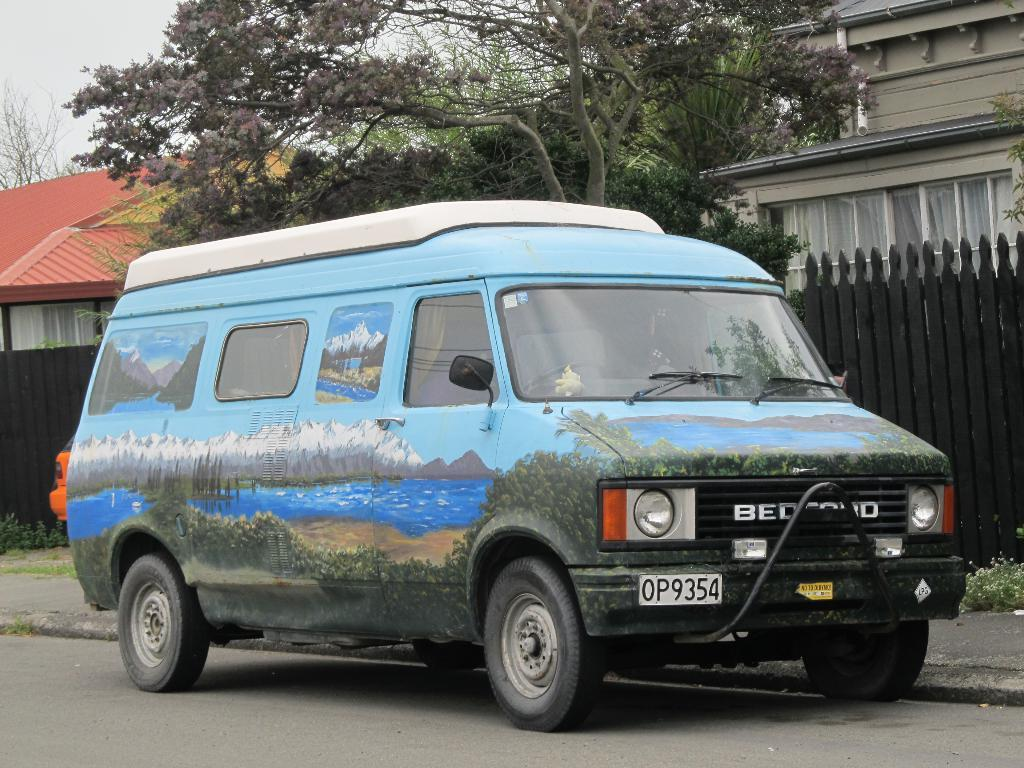What is the main subject in the middle of the image? There is a van in the middle of the image. Where is the van located? The van is on the road. What can be seen beside the van? There are trees beside the van. What else is visible in the image besides the van and trees? There are buildings, a wooden fence, and a car visible in the image. How many books can be seen in the image? There are no books present in the image. 